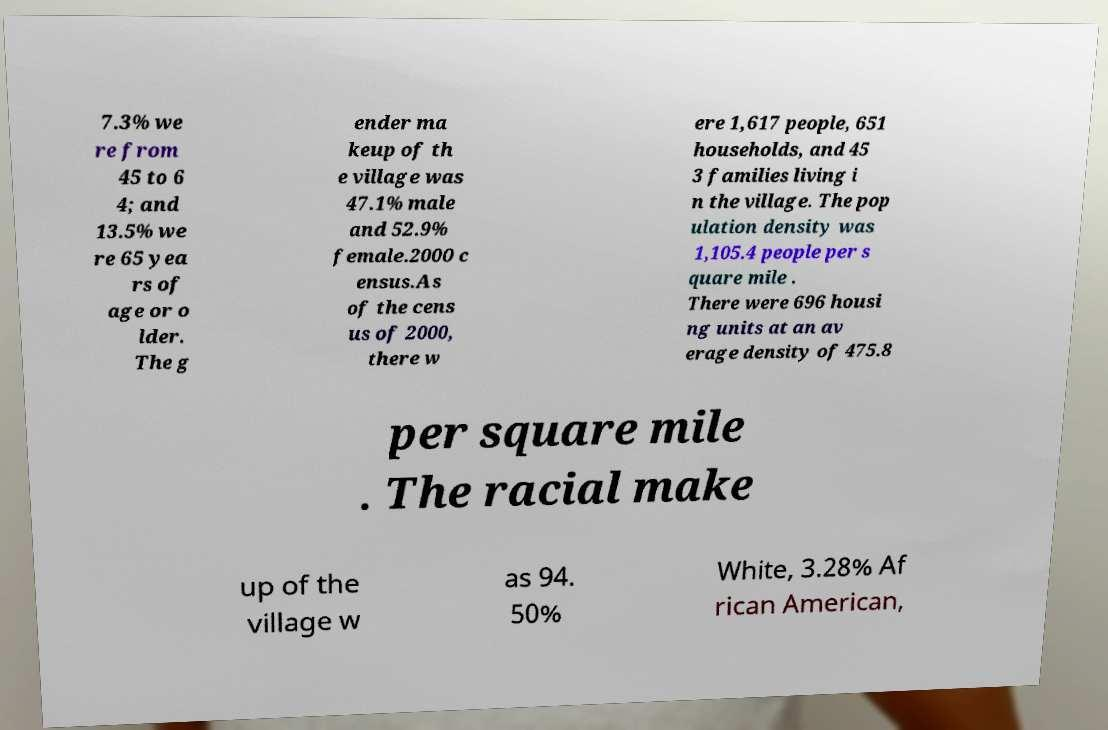Please identify and transcribe the text found in this image. 7.3% we re from 45 to 6 4; and 13.5% we re 65 yea rs of age or o lder. The g ender ma keup of th e village was 47.1% male and 52.9% female.2000 c ensus.As of the cens us of 2000, there w ere 1,617 people, 651 households, and 45 3 families living i n the village. The pop ulation density was 1,105.4 people per s quare mile . There were 696 housi ng units at an av erage density of 475.8 per square mile . The racial make up of the village w as 94. 50% White, 3.28% Af rican American, 